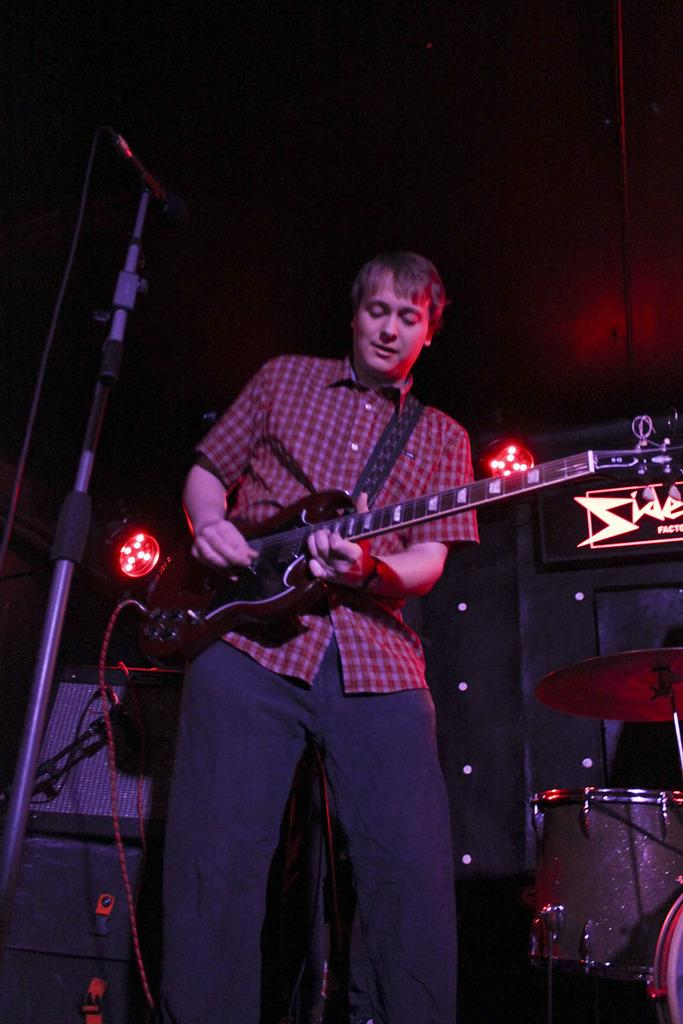What is the main subject of the image? The main subject of the image is a man standing in the center. What is the man holding in the image? The man is holding a guitar. Are there any other musical instruments visible in the image? Yes, there are musical instruments visible behind the man. What type of cellar can be seen in the background of the image? There is no cellar present in the image; it features a man holding a guitar with other musical instruments visible behind him. How does the friction between the guitar strings affect the sound produced in the image? The image does not provide enough information to determine the sound produced or the friction between the guitar strings. 